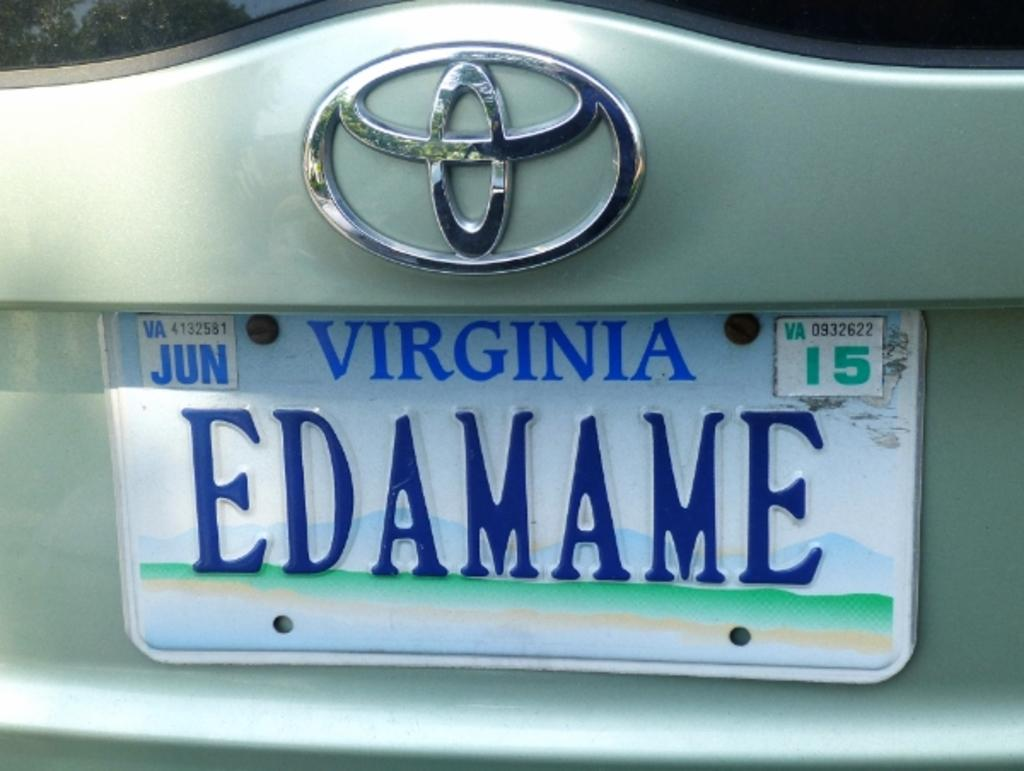Provide a one-sentence caption for the provided image. A white and blue Virginia license plate is labeled EDAMAME. 